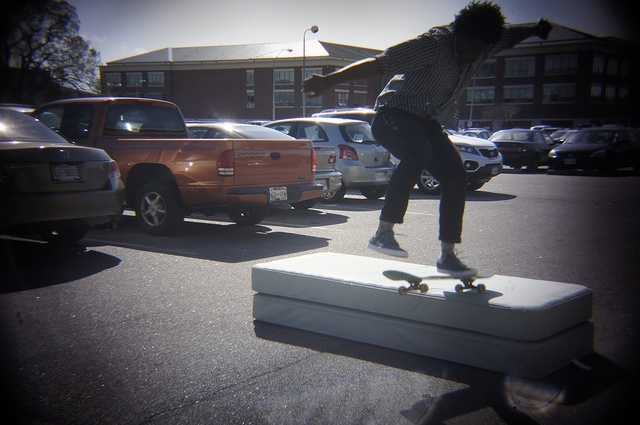Describe the objects in this image and their specific colors. I can see bed in black, gray, and white tones, truck in black, brown, and maroon tones, people in black, gray, and darkgray tones, car in black, gray, and darkgray tones, and car in black and gray tones in this image. 